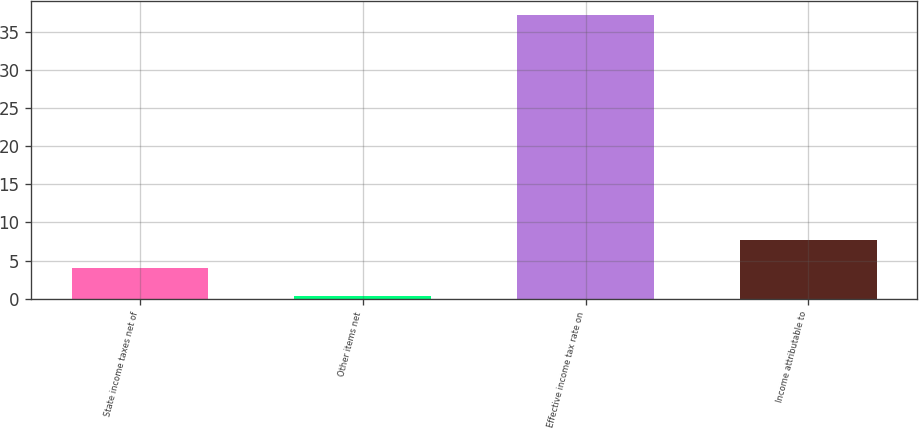Convert chart. <chart><loc_0><loc_0><loc_500><loc_500><bar_chart><fcel>State income taxes net of<fcel>Other items net<fcel>Effective income tax rate on<fcel>Income attributable to<nl><fcel>4.08<fcel>0.4<fcel>37.2<fcel>7.76<nl></chart> 